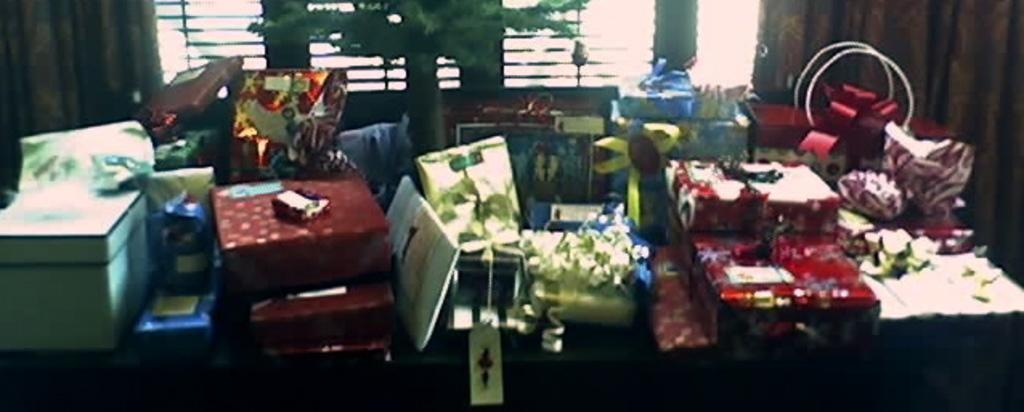What is the main subject in the foreground of the image? There are many gift boxes in the foreground of the image. What can be seen in the middle of the image? There is a tree in the middle of the image. What is present in the background of the image? There are two curtains, one on each side, and a window in the background of the image. What type of suit is the band wearing in the image? There is no band or suit present in the image. How many screws can be seen holding the tree in place in the image? There are no screws visible in the image, and the tree is not being held in place by any visible means. 